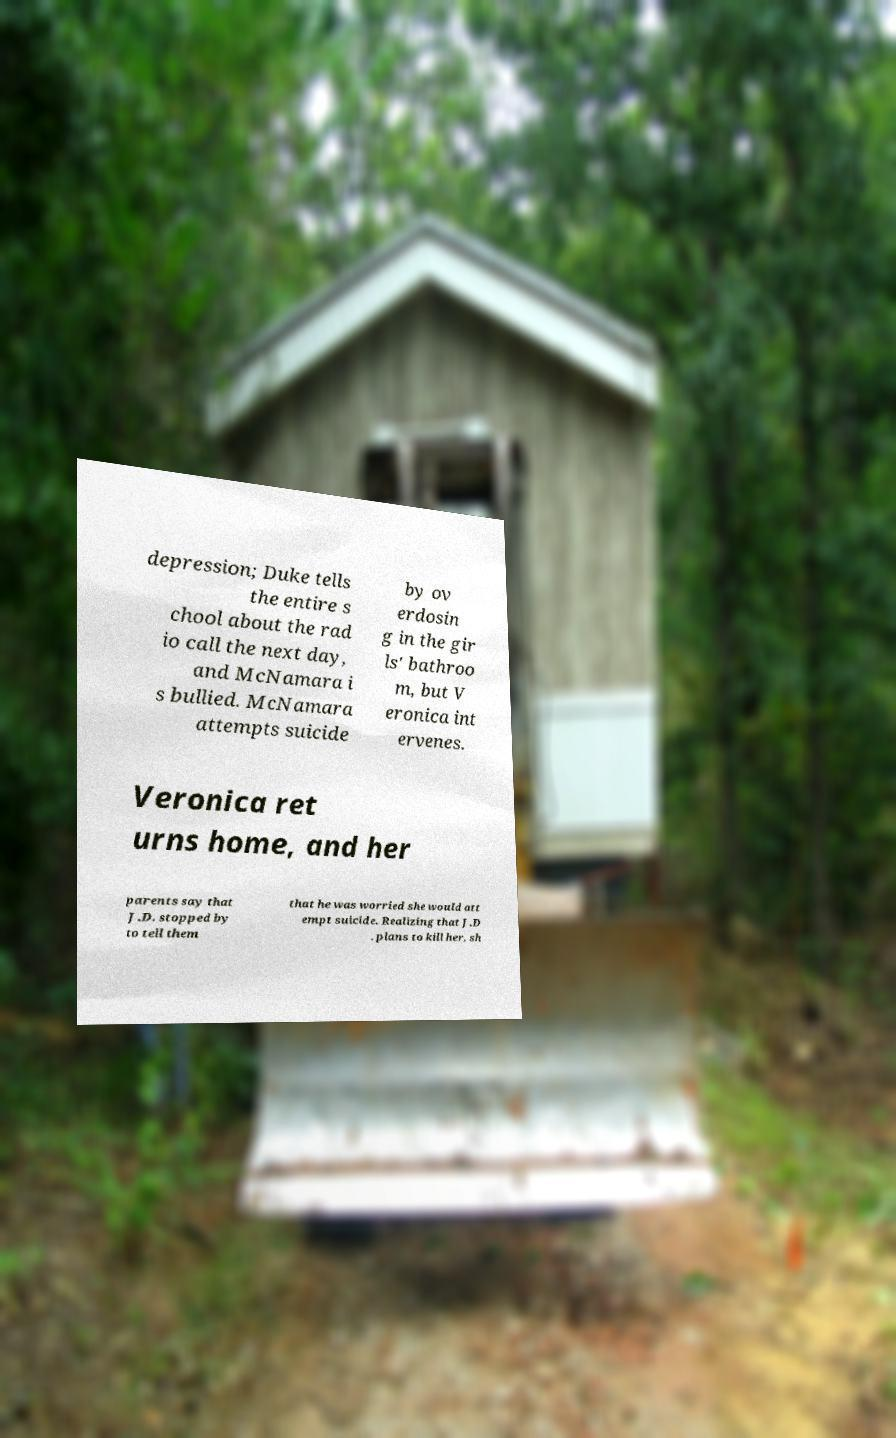What messages or text are displayed in this image? I need them in a readable, typed format. depression; Duke tells the entire s chool about the rad io call the next day, and McNamara i s bullied. McNamara attempts suicide by ov erdosin g in the gir ls' bathroo m, but V eronica int ervenes. Veronica ret urns home, and her parents say that J.D. stopped by to tell them that he was worried she would att empt suicide. Realizing that J.D . plans to kill her, sh 